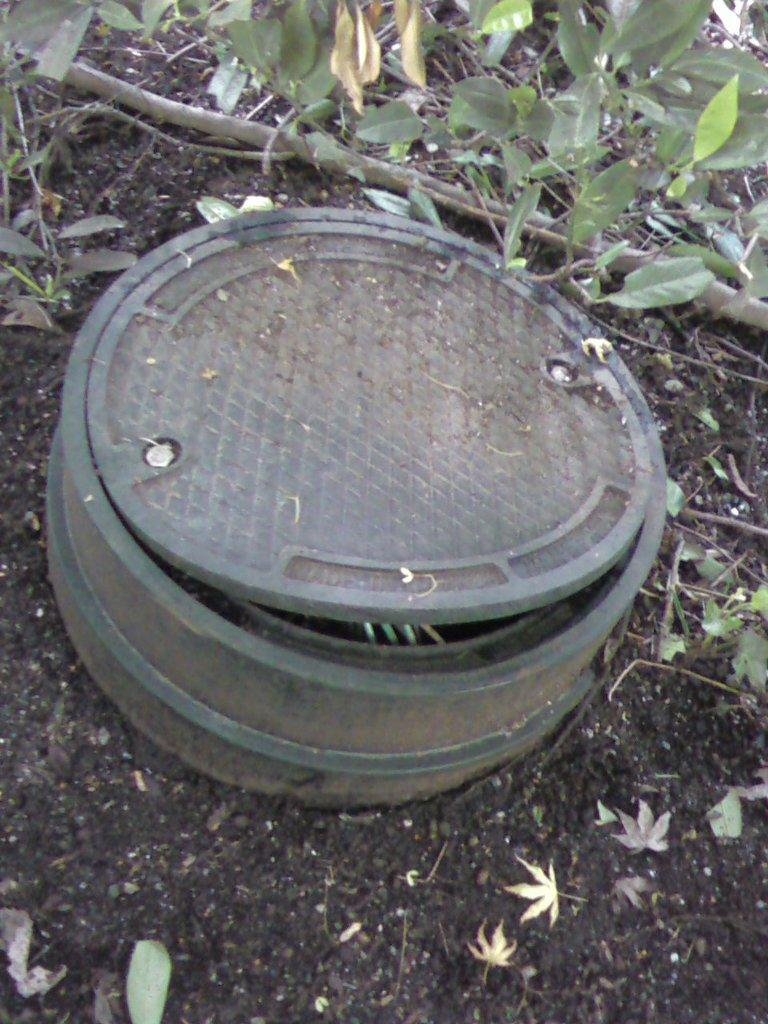What is the main object in the foreground of the image? There is an object in the foreground of the image, but the specific object is not mentioned in the facts. What can be seen in the distance in the image? There are trees visible in the background of the image. What is present at the bottom of the image? There is mud at the bottom of the image. What type of vegetation is present in the image? There are leaves and a tree branch in the image. What part of the human body is responsible for the science of the image? There is no reference to the human body or science in the image, so this question cannot be answered definitively. 